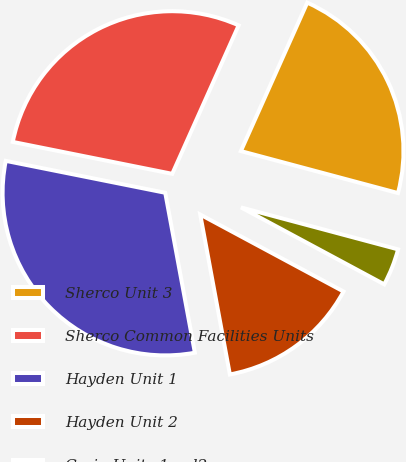Convert chart to OTSL. <chart><loc_0><loc_0><loc_500><loc_500><pie_chart><fcel>Sherco Unit 3<fcel>Sherco Common Facilities Units<fcel>Hayden Unit 1<fcel>Hayden Unit 2<fcel>Craig Units 1and2<nl><fcel>22.46%<fcel>28.55%<fcel>31.06%<fcel>14.24%<fcel>3.69%<nl></chart> 